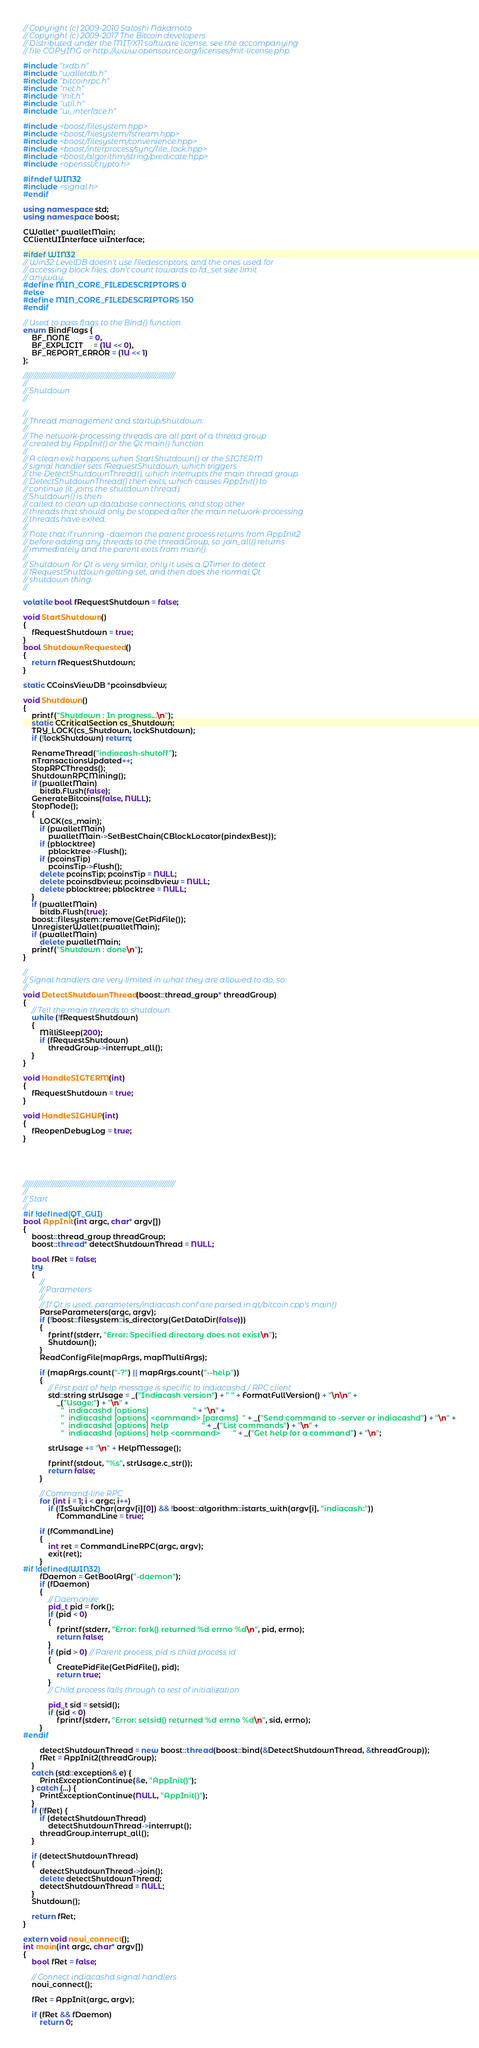Convert code to text. <code><loc_0><loc_0><loc_500><loc_500><_C++_>// Copyright (c) 2009-2010 Satoshi Nakamoto
// Copyright (c) 2009-2017 The Bitcoin developers
// Distributed under the MIT/X11 software license, see the accompanying
// file COPYING or http://www.opensource.org/licenses/mit-license.php.

#include "txdb.h"
#include "walletdb.h"
#include "bitcoinrpc.h"
#include "net.h"
#include "init.h"
#include "util.h"
#include "ui_interface.h"

#include <boost/filesystem.hpp>
#include <boost/filesystem/fstream.hpp>
#include <boost/filesystem/convenience.hpp>
#include <boost/interprocess/sync/file_lock.hpp>
#include <boost/algorithm/string/predicate.hpp>
#include <openssl/crypto.h>

#ifndef WIN32
#include <signal.h>
#endif

using namespace std;
using namespace boost;

CWallet* pwalletMain;
CClientUIInterface uiInterface;

#ifdef WIN32
// Win32 LevelDB doesn't use filedescriptors, and the ones used for
// accessing block files, don't count towards to fd_set size limit
// anyway.
#define MIN_CORE_FILEDESCRIPTORS 0
#else
#define MIN_CORE_FILEDESCRIPTORS 150
#endif

// Used to pass flags to the Bind() function
enum BindFlags {
    BF_NONE         = 0,
    BF_EXPLICIT     = (1U << 0),
    BF_REPORT_ERROR = (1U << 1)
};

//////////////////////////////////////////////////////////////////////////////
//
// Shutdown
//

//
// Thread management and startup/shutdown:
//
// The network-processing threads are all part of a thread group
// created by AppInit() or the Qt main() function.
//
// A clean exit happens when StartShutdown() or the SIGTERM
// signal handler sets fRequestShutdown, which triggers
// the DetectShutdownThread(), which interrupts the main thread group.
// DetectShutdownThread() then exits, which causes AppInit() to
// continue (it .joins the shutdown thread).
// Shutdown() is then
// called to clean up database connections, and stop other
// threads that should only be stopped after the main network-processing
// threads have exited.
//
// Note that if running -daemon the parent process returns from AppInit2
// before adding any threads to the threadGroup, so .join_all() returns
// immediately and the parent exits from main().
//
// Shutdown for Qt is very similar, only it uses a QTimer to detect
// fRequestShutdown getting set, and then does the normal Qt
// shutdown thing.
//

volatile bool fRequestShutdown = false;

void StartShutdown()
{
    fRequestShutdown = true;
}
bool ShutdownRequested()
{
    return fRequestShutdown;
}

static CCoinsViewDB *pcoinsdbview;

void Shutdown()
{
    printf("Shutdown : In progress...\n");
    static CCriticalSection cs_Shutdown;
    TRY_LOCK(cs_Shutdown, lockShutdown);
    if (!lockShutdown) return;

    RenameThread("indiacash-shutoff");
    nTransactionsUpdated++;
    StopRPCThreads();
    ShutdownRPCMining();
    if (pwalletMain)
        bitdb.Flush(false);
    GenerateBitcoins(false, NULL);
    StopNode();
    {
        LOCK(cs_main);
        if (pwalletMain)
            pwalletMain->SetBestChain(CBlockLocator(pindexBest));
        if (pblocktree)
            pblocktree->Flush();
        if (pcoinsTip)
            pcoinsTip->Flush();
        delete pcoinsTip; pcoinsTip = NULL;
        delete pcoinsdbview; pcoinsdbview = NULL;
        delete pblocktree; pblocktree = NULL;
    }
    if (pwalletMain)
        bitdb.Flush(true);
    boost::filesystem::remove(GetPidFile());
    UnregisterWallet(pwalletMain);
    if (pwalletMain)
        delete pwalletMain;
    printf("Shutdown : done\n");
}

//
// Signal handlers are very limited in what they are allowed to do, so:
//
void DetectShutdownThread(boost::thread_group* threadGroup)
{
    // Tell the main threads to shutdown.
    while (!fRequestShutdown)
    {
        MilliSleep(200);
        if (fRequestShutdown)
            threadGroup->interrupt_all();
    }
}

void HandleSIGTERM(int)
{
    fRequestShutdown = true;
}

void HandleSIGHUP(int)
{
    fReopenDebugLog = true;
}





//////////////////////////////////////////////////////////////////////////////
//
// Start
//
#if !defined(QT_GUI)
bool AppInit(int argc, char* argv[])
{
    boost::thread_group threadGroup;
    boost::thread* detectShutdownThread = NULL;

    bool fRet = false;
    try
    {
        //
        // Parameters
        //
        // If Qt is used, parameters/indiacash.conf are parsed in qt/bitcoin.cpp's main()
        ParseParameters(argc, argv);
        if (!boost::filesystem::is_directory(GetDataDir(false)))
        {
            fprintf(stderr, "Error: Specified directory does not exist\n");
            Shutdown();
        }
        ReadConfigFile(mapArgs, mapMultiArgs);

        if (mapArgs.count("-?") || mapArgs.count("--help"))
        {
            // First part of help message is specific to indiacashd / RPC client
            std::string strUsage = _("Indiacash version") + " " + FormatFullVersion() + "\n\n" +
                _("Usage:") + "\n" +
                  "  indiacashd [options]                     " + "\n" +
                  "  indiacashd [options] <command> [params]  " + _("Send command to -server or indiacashd") + "\n" +
                  "  indiacashd [options] help                " + _("List commands") + "\n" +
                  "  indiacashd [options] help <command>      " + _("Get help for a command") + "\n";

            strUsage += "\n" + HelpMessage();

            fprintf(stdout, "%s", strUsage.c_str());
            return false;
        }

        // Command-line RPC
        for (int i = 1; i < argc; i++)
            if (!IsSwitchChar(argv[i][0]) && !boost::algorithm::istarts_with(argv[i], "indiacash:"))
                fCommandLine = true;

        if (fCommandLine)
        {
            int ret = CommandLineRPC(argc, argv);
            exit(ret);
        }
#if !defined(WIN32)
        fDaemon = GetBoolArg("-daemon");
        if (fDaemon)
        {
            // Daemonize
            pid_t pid = fork();
            if (pid < 0)
            {
                fprintf(stderr, "Error: fork() returned %d errno %d\n", pid, errno);
                return false;
            }
            if (pid > 0) // Parent process, pid is child process id
            {
                CreatePidFile(GetPidFile(), pid);
                return true;
            }
            // Child process falls through to rest of initialization

            pid_t sid = setsid();
            if (sid < 0)
                fprintf(stderr, "Error: setsid() returned %d errno %d\n", sid, errno);
        }
#endif

        detectShutdownThread = new boost::thread(boost::bind(&DetectShutdownThread, &threadGroup));
        fRet = AppInit2(threadGroup);
    }
    catch (std::exception& e) {
        PrintExceptionContinue(&e, "AppInit()");
    } catch (...) {
        PrintExceptionContinue(NULL, "AppInit()");
    }
    if (!fRet) {
        if (detectShutdownThread)
            detectShutdownThread->interrupt();
        threadGroup.interrupt_all();
    }

    if (detectShutdownThread)
    {
        detectShutdownThread->join();
        delete detectShutdownThread;
        detectShutdownThread = NULL;
    }
    Shutdown();

    return fRet;
}

extern void noui_connect();
int main(int argc, char* argv[])
{
    bool fRet = false;

    // Connect indiacashd signal handlers
    noui_connect();

    fRet = AppInit(argc, argv);

    if (fRet && fDaemon)
        return 0;
</code> 